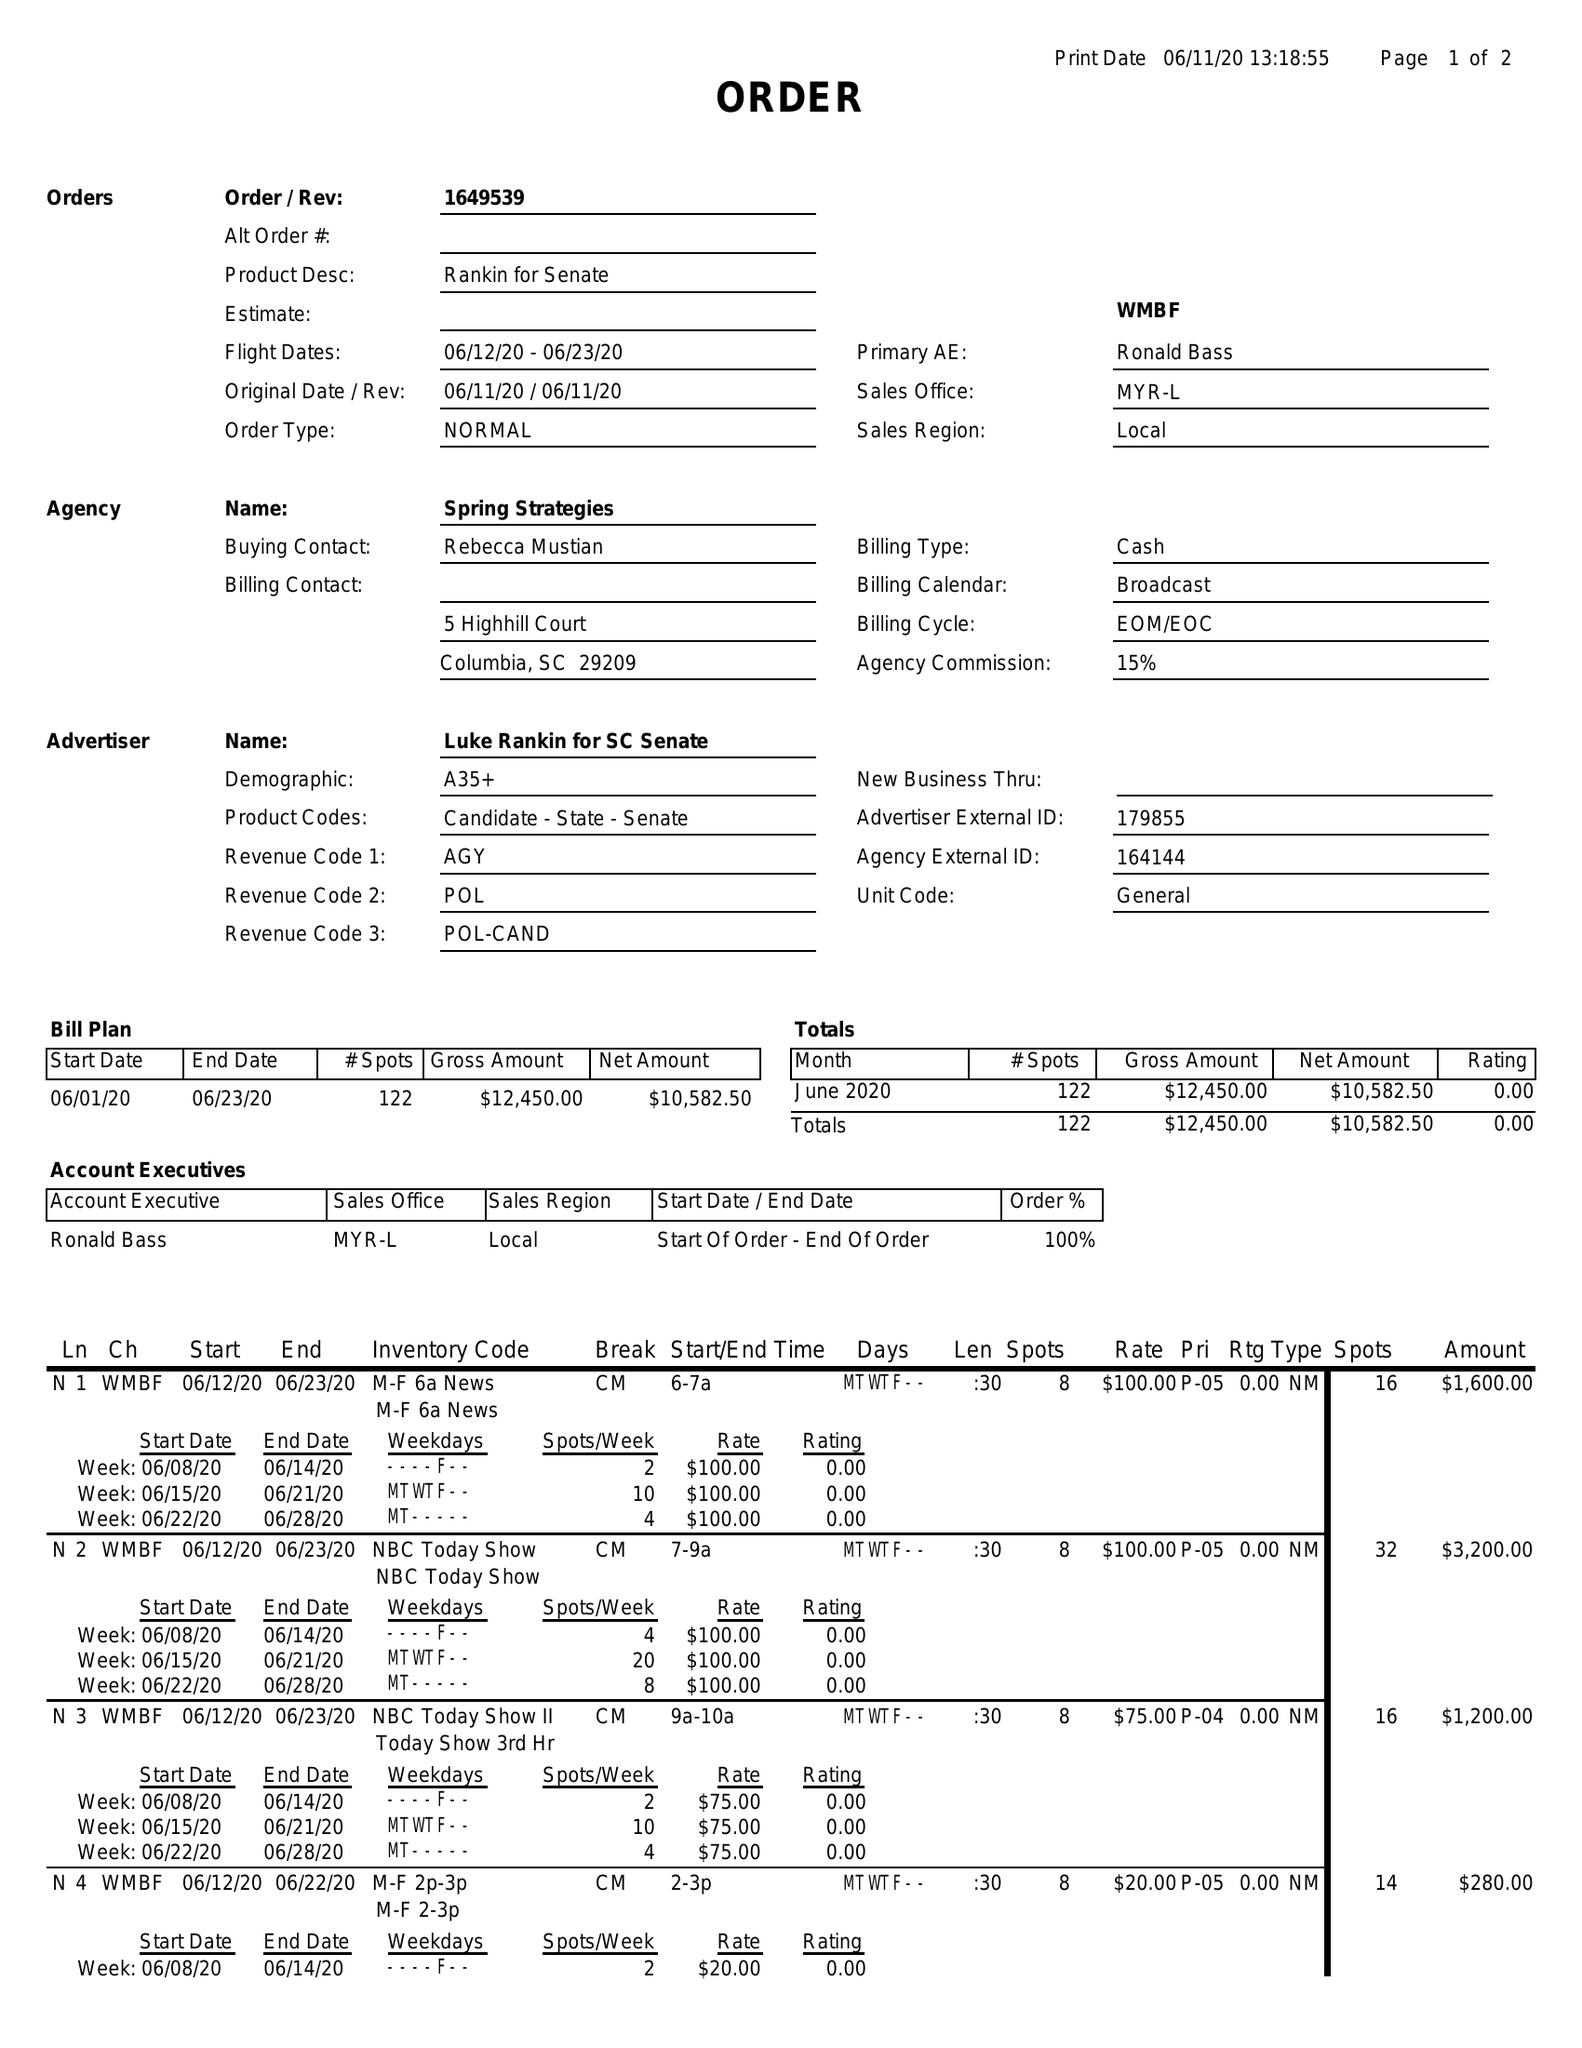What is the value for the advertiser?
Answer the question using a single word or phrase. LUKE RANKIN FOR SC SENATE 